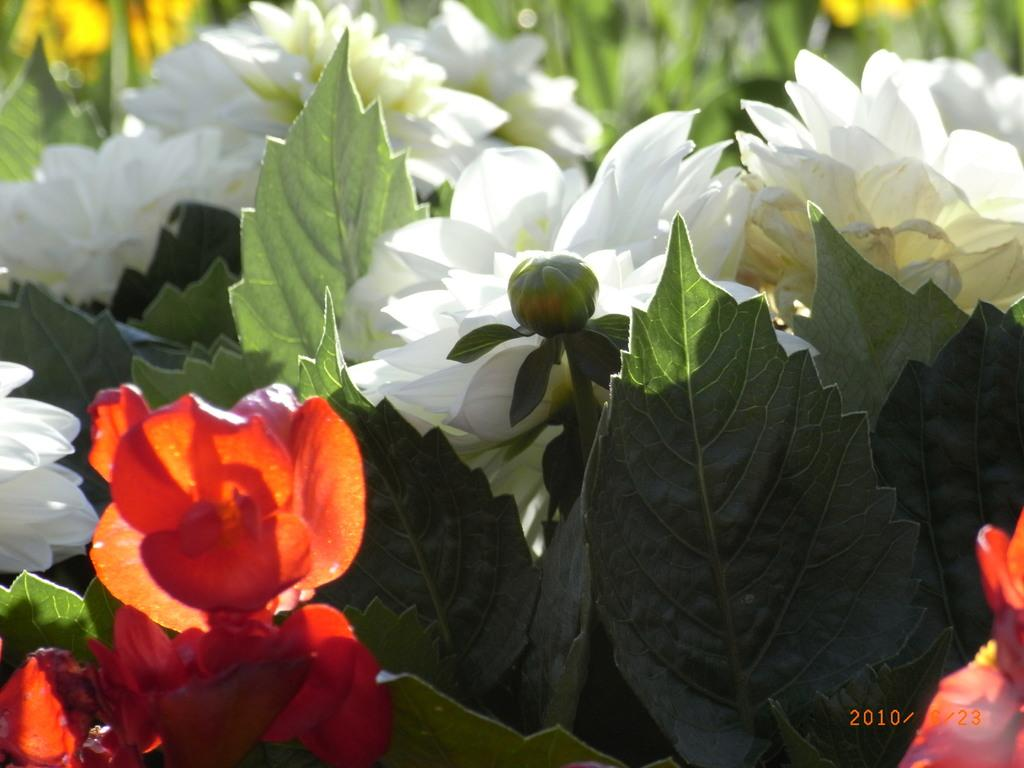What type of plants are visible in the image? There are plants with flowers in the image. What other features can be seen on the plants? The plants have leaves in the image, and there is a bud on the plants. Can you describe the background of the image? The background of the image is blurred. Is there any additional information or markings on the image? Yes, there is a watermark on the image. What type of stove is visible in the image? There is no stove present in the image; it features plants with flowers, leaves, and buds. What type of art can be seen on the plants in the image? The plants in the image are not a form of art; they are living organisms with flowers, leaves, and buds. 